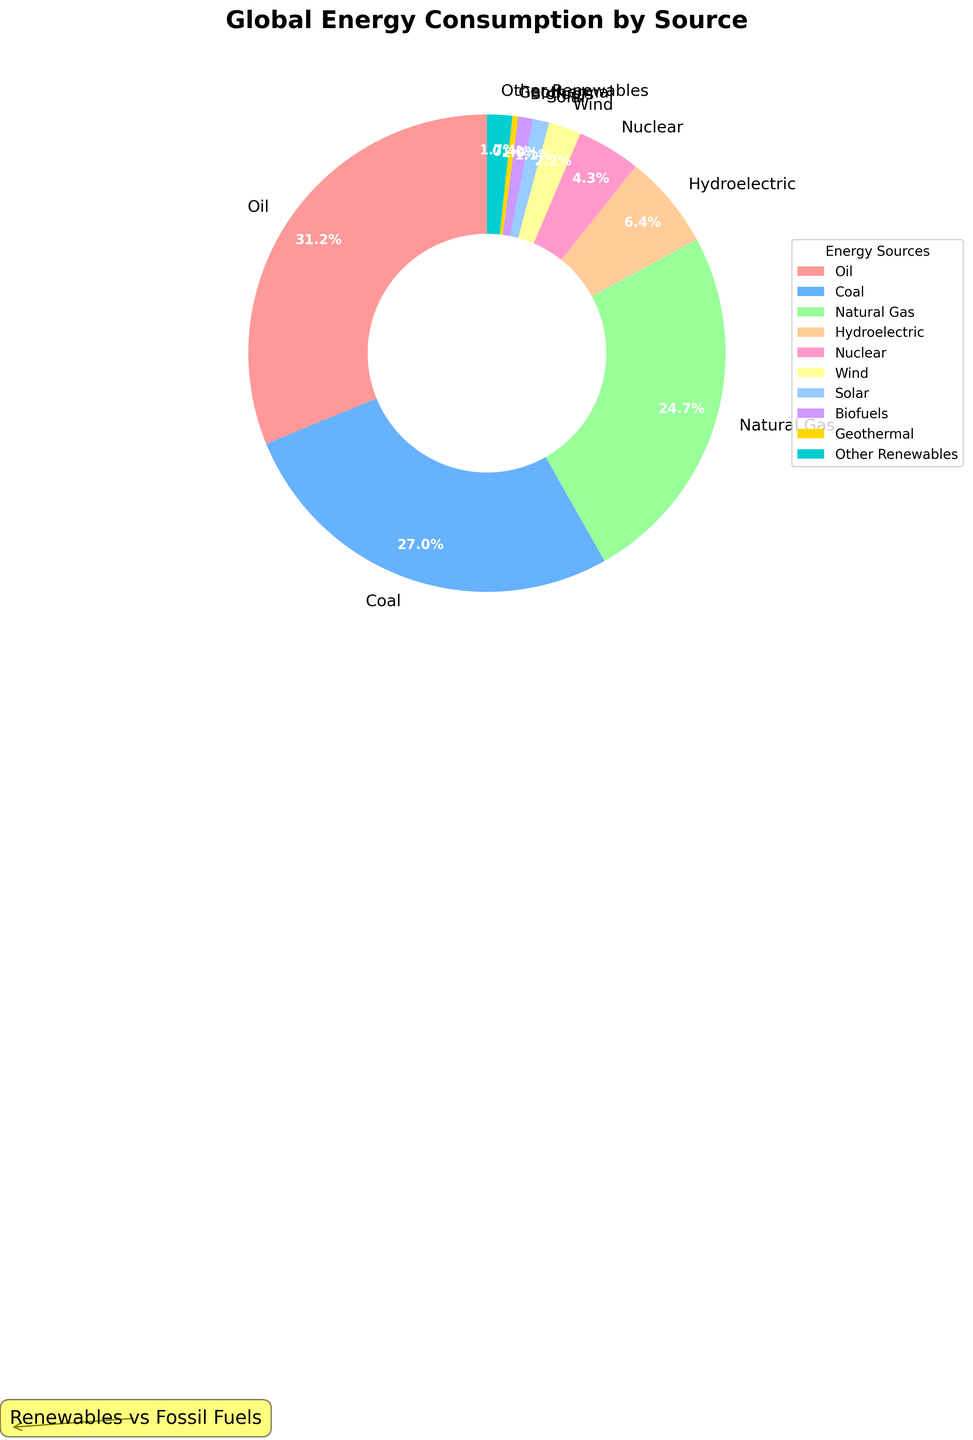What percentage of global energy consumption comes from fossil fuels? Fossil fuels include Oil, Coal, and Natural Gas. Adding their percentages: 31.2 (Oil) + 27.0 (Coal) + 24.7 (Natural Gas) = 82.9. Hence, 82.9% of global energy consumption comes from fossil fuels.
Answer: 82.9% Compare the contribution of renewables and fossil fuels to global energy consumption. Which is higher? Fossil fuels contribute 82.9% (from previous computation), and renewables include Hydroelectric (6.4%), Wind (2.2%), Solar (1.1%), Biofuels (1.0%), Geothermal (0.4%), and Other Renewables (1.7%). Adding renewables: 6.4 + 2.2 + 1.1 + 1.0 + 0.4 + 1.7 = 12.8. Thus, fossil fuels (82.9%) contribute more than renewables (12.8%).
Answer: Fossil fuels Is the combined percentage of Wind and Solar energy more or less than the percentage from Nuclear energy? The combined percentage of Wind and Solar: 2.2 (Wind) + 1.1 (Solar) = 3.3. The percentage of Nuclear energy is 4.3%. Therefore, Wind and Solar together (3.3%) is less than Nuclear energy (4.3%).
Answer: Less What is the gap between the highest and lowest percentage energy sources in the chart? The highest percentage is Oil at 31.2% and the lowest is Geothermal at 0.4%. The gap is calculated as 31.2% - 0.4% = 30.8%.
Answer: 30.8% Which energy source has the smallest contribution and what is its percentage? The energy source with the smallest contribution is Geothermal with a percentage of 0.4%.
Answer: Geothermal, 0.4% Are all the renewable energy sources combined more or less than Coal energy consumption? Adding renewables: Hydroelectric (6.4%), Wind (2.2%), Solar (1.1%), Biofuels (1.0%), Geothermal (0.4%), and Other Renewables (1.7%). Total = 6.4 + 2.2 + 1.1 + 1.0 + 0.4 + 1.7 = 12.8%. Coal alone accounts for 27.0%. Therefore, all renewables combined (12.8%) are less than Coal (27.0%).
Answer: Less What is the percentage difference between Natural Gas and Nuclear energy? The percentage of Natural Gas is 24.7% and Nuclear is 4.3%. The difference is calculated as 24.7% - 4.3% = 20.4%.
Answer: 20.4% If we sum Biofuels, Geothermal, and Other Renewables, does it exceed Wind energy consumption? Adding Biofuels (1.0%), Geothermal (0.4%), and Other Renewables (1.7%): 1.0 + 0.4 + 1.7 = 3.1%. Wind energy is 2.2%. Therefore, this combination (3.1%) does exceed Wind (2.2%).
Answer: Yes Which energy source has a larger percentage, Hydroelectric or Natural Gas? The percentage of Hydroelectric is 6.4% and Natural Gas is 24.7%. Natural Gas has a larger percentage compared to Hydroelectric.
Answer: Natural Gas What proportion of global energy consumption comes from non-renewable sources excluding fossil fuels? Non-renewable sources excluding fossil fuels include only Nuclear energy, which is 4.3%.
Answer: 4.3% 